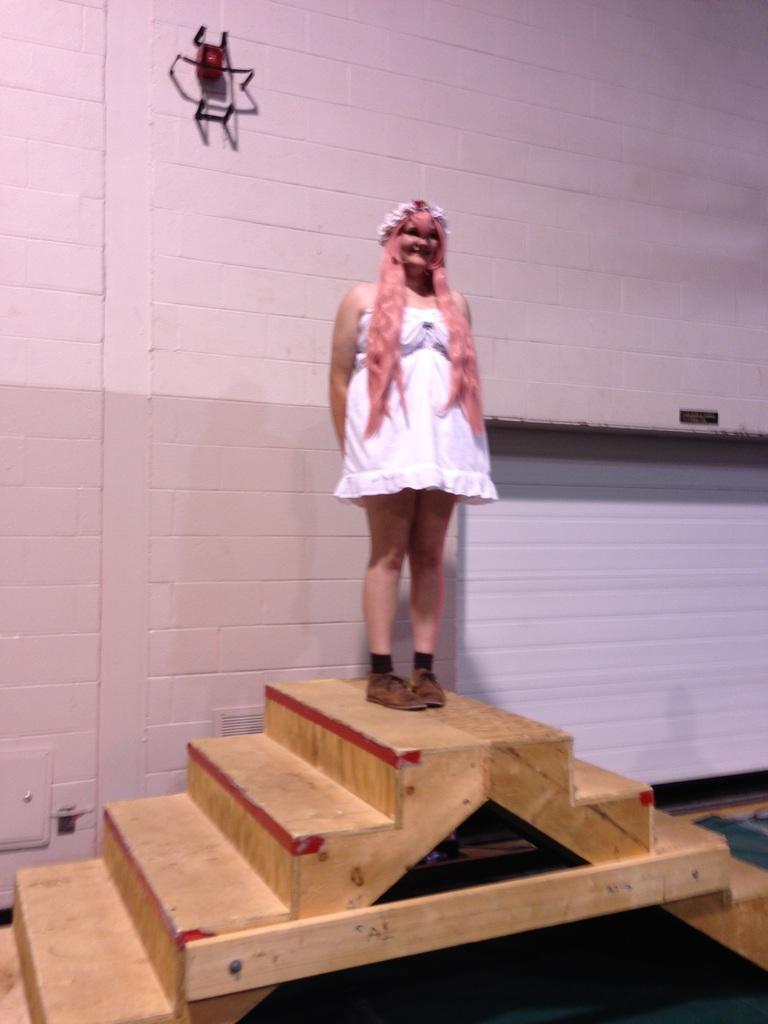Could you give a brief overview of what you see in this image? In this image I can see a woman wearing a white color skirt standing on staircase and I can see the wall back side of the woman and she is smiling. 